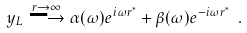Convert formula to latex. <formula><loc_0><loc_0><loc_500><loc_500>y _ { L } \stackrel { r \rightarrow \infty } { \longrightarrow } \alpha ( \omega ) e ^ { i \omega r ^ { * } } + \beta ( \omega ) e ^ { - i \omega r ^ { * } } \ .</formula> 